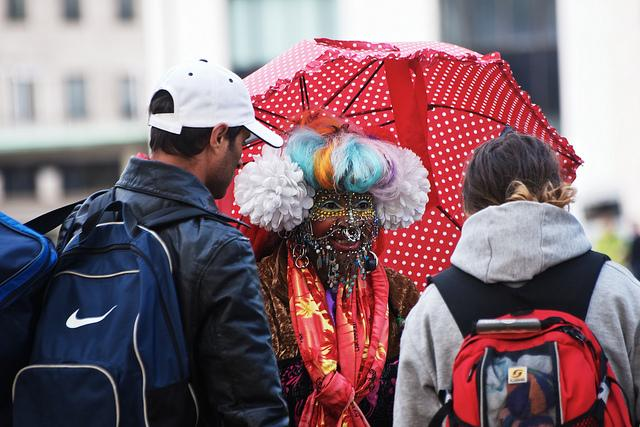What does the woman have all over her face?

Choices:
A) hair
B) piercings
C) stickers
D) food piercings 